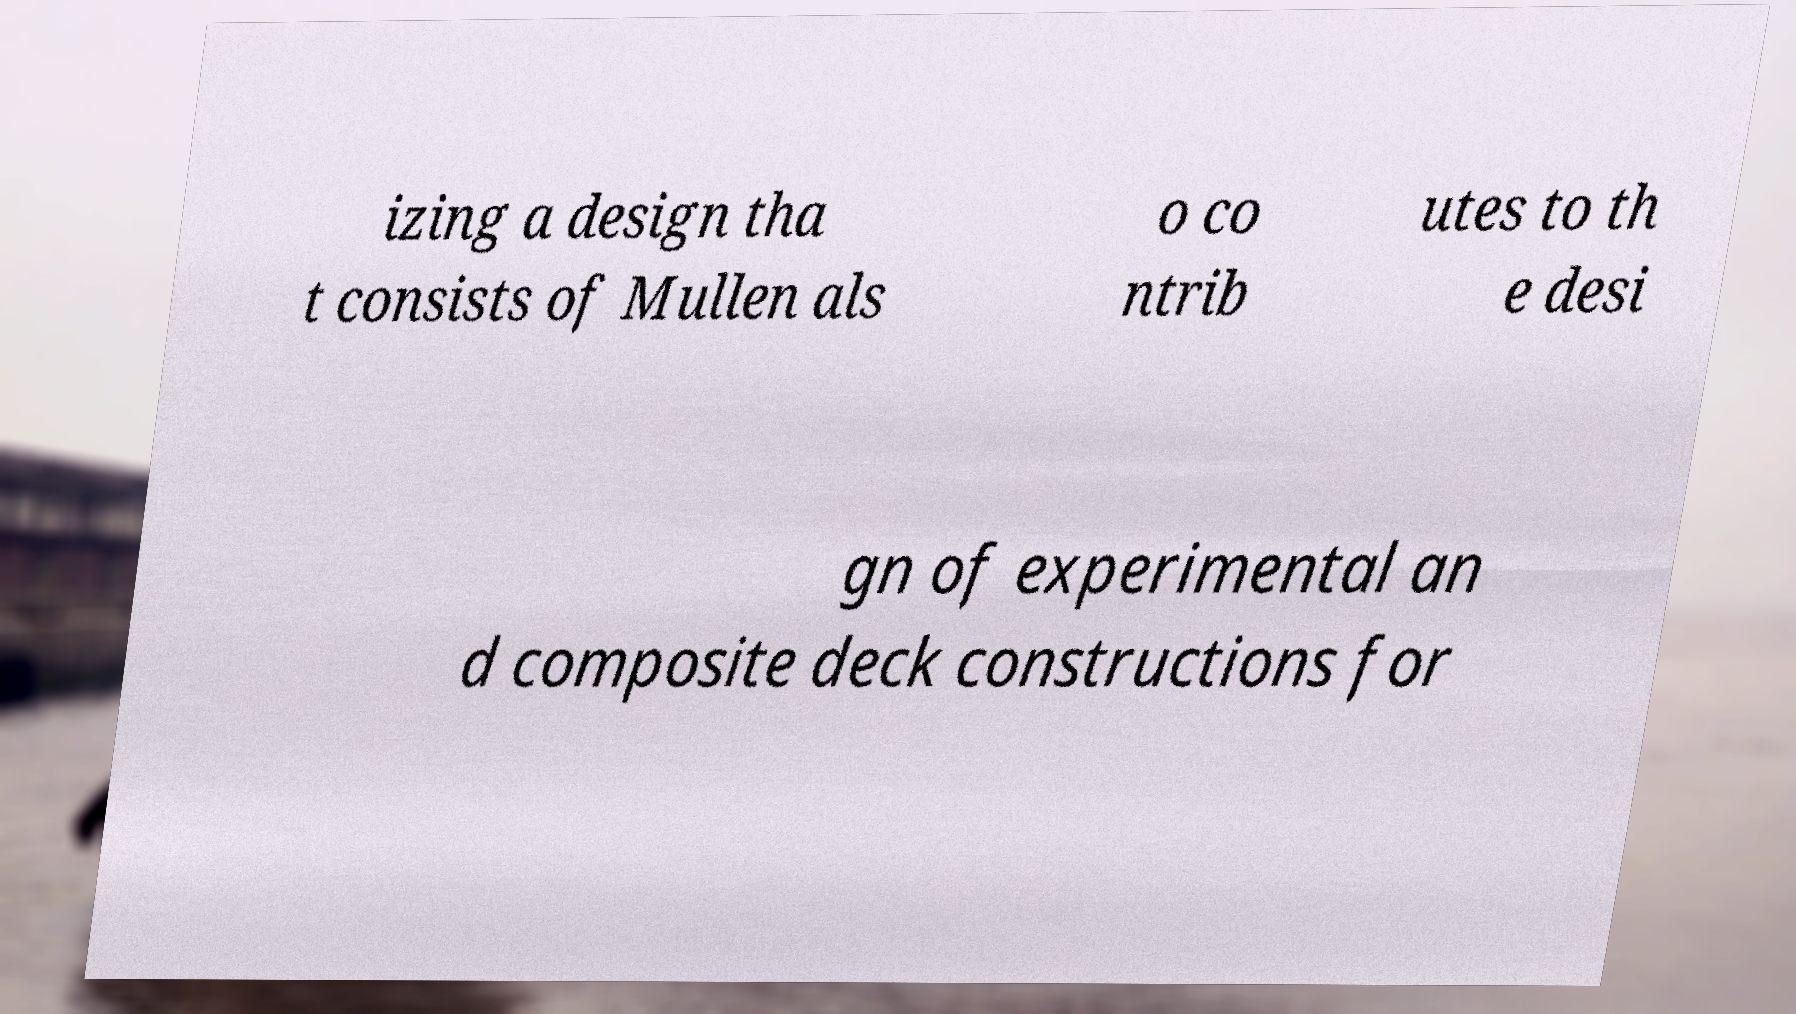Could you assist in decoding the text presented in this image and type it out clearly? izing a design tha t consists of Mullen als o co ntrib utes to th e desi gn of experimental an d composite deck constructions for 